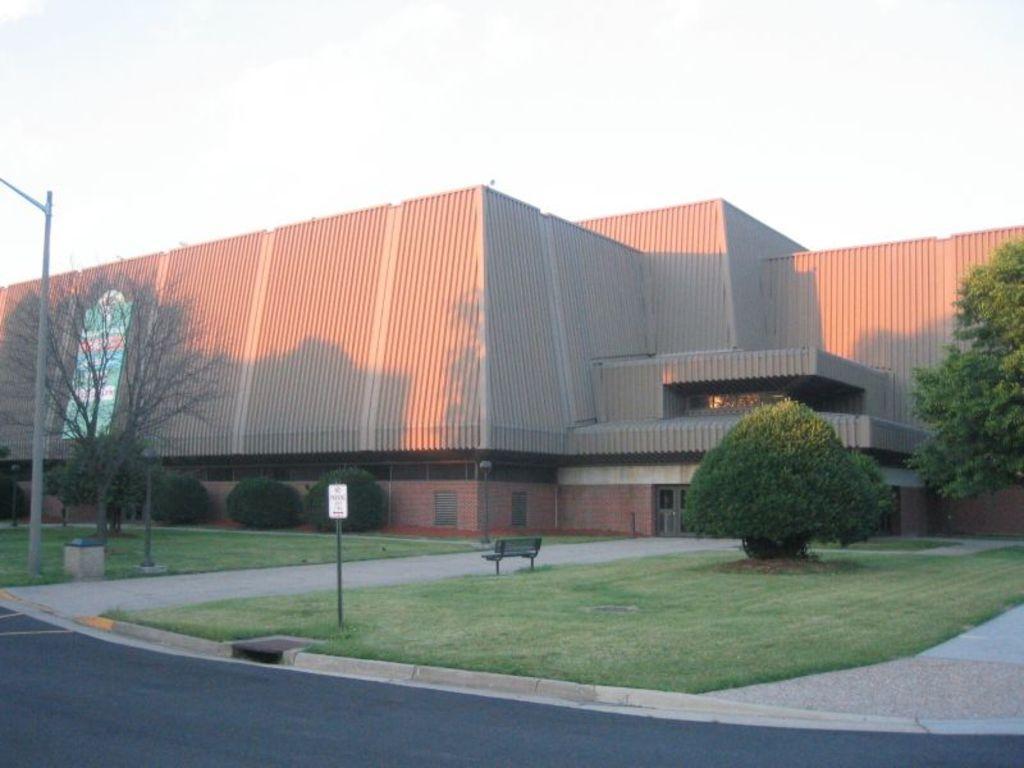How would you summarize this image in a sentence or two? In the image we can see a building, trees and plants. We can even see grass, bench and pole. Here we can see the road, board and the sky. 